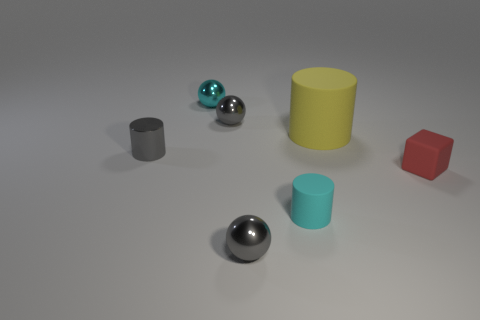There is a small sphere that is the same color as the tiny rubber cylinder; what is it made of?
Offer a very short reply. Metal. Is the size of the matte block the same as the cyan metal object?
Keep it short and to the point. Yes. How many things are big yellow objects or big yellow blocks?
Provide a short and direct response. 1. What shape is the tiny cyan thing in front of the tiny gray metal ball behind the gray thing that is in front of the red thing?
Provide a short and direct response. Cylinder. Are the tiny cylinder in front of the red block and the gray object to the left of the cyan sphere made of the same material?
Make the answer very short. No. There is a small gray object that is the same shape as the large yellow object; what is its material?
Ensure brevity in your answer.  Metal. Is there any other thing that is the same size as the red matte object?
Make the answer very short. Yes. Does the cyan object in front of the large yellow cylinder have the same shape as the small gray object that is in front of the small shiny cylinder?
Offer a very short reply. No. Are there fewer cyan metallic balls in front of the large cylinder than large matte things that are in front of the small cyan rubber thing?
Your answer should be very brief. No. How many other objects are there of the same shape as the large matte object?
Offer a terse response. 2. 